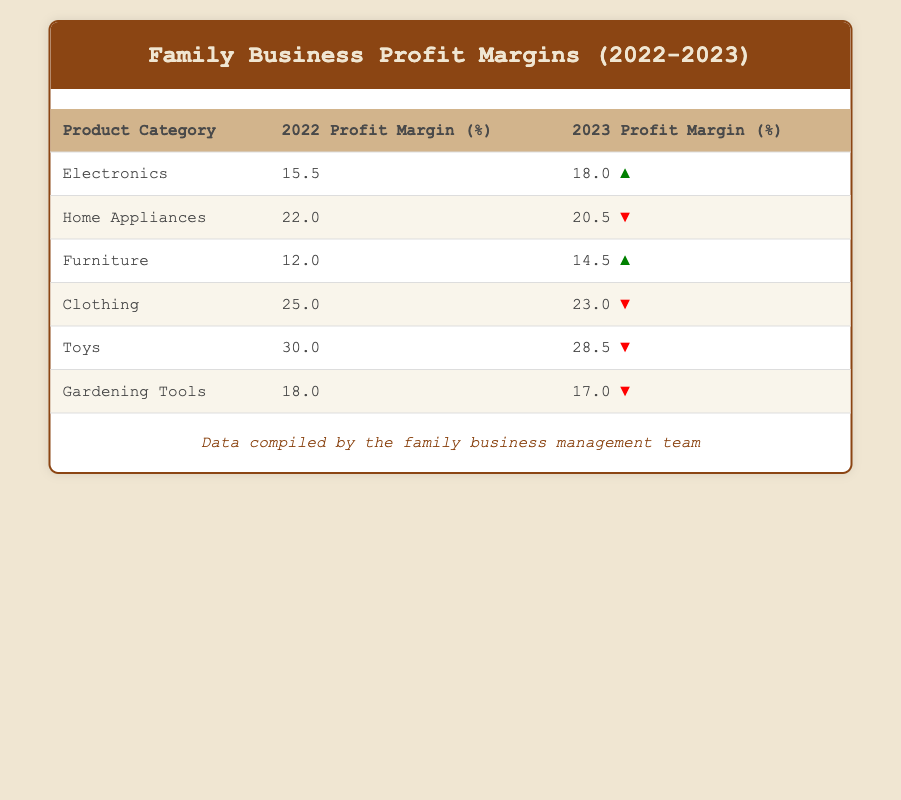What was the profit margin for Home Appliances in 2022? According to the table, the profit margin for Home Appliances in 2022 was listed as 22.0%.
Answer: 22.0% Which product category had the highest profit margin in 2023? Looking at the table, Toys had the highest profit margin in 2023 at 28.5%.
Answer: Toys What is the difference in profit margin for Electronics between 2022 and 2023? To find the difference, subtract the profit margin for 2022 (15.5%) from that of 2023 (18.0%), which gives 18.0% - 15.5% = 2.5%.
Answer: 2.5% Did any product categories experience an increase in profit margin from 2022 to 2023? Yes, both Electronics and Furniture experienced an increase in profit margin from 2022 to 2023.
Answer: Yes What is the average profit margin for Gardening Tools across the two years? The profit margins for Gardening Tools are 18.0% in 2022 and 17.0% in 2023. To find the average, we sum these values (18.0% + 17.0% = 35.0%) and then divide by 2, giving us an average of 35.0% / 2 = 17.5%.
Answer: 17.5% Which product category had the lowest profit margin in both years? From the table, it can be seen that Furniture had the lowest profit margin in both years, with 12.0% in 2022 and 14.5% in 2023.
Answer: Furniture What was the trend for Clothing's profit margin from 2022 to 2023? The profit margin for Clothing decreased from 25.0% in 2022 to 23.0% in 2023, indicating a downward trend.
Answer: Downward Were profit margins for Toys higher or lower in 2023 compared to 2022? The profit margin for Toys was lower in 2023 (28.5%) compared to 2022 (30.0%), indicating a decrease.
Answer: Lower What was the total profit margin for all product categories in 2022? To find the total profit margin for 2022, we sum the profit margins: 15.5% + 22.0% + 12.0% + 25.0% + 30.0% + 18.0% = 122.5%.
Answer: 122.5% 